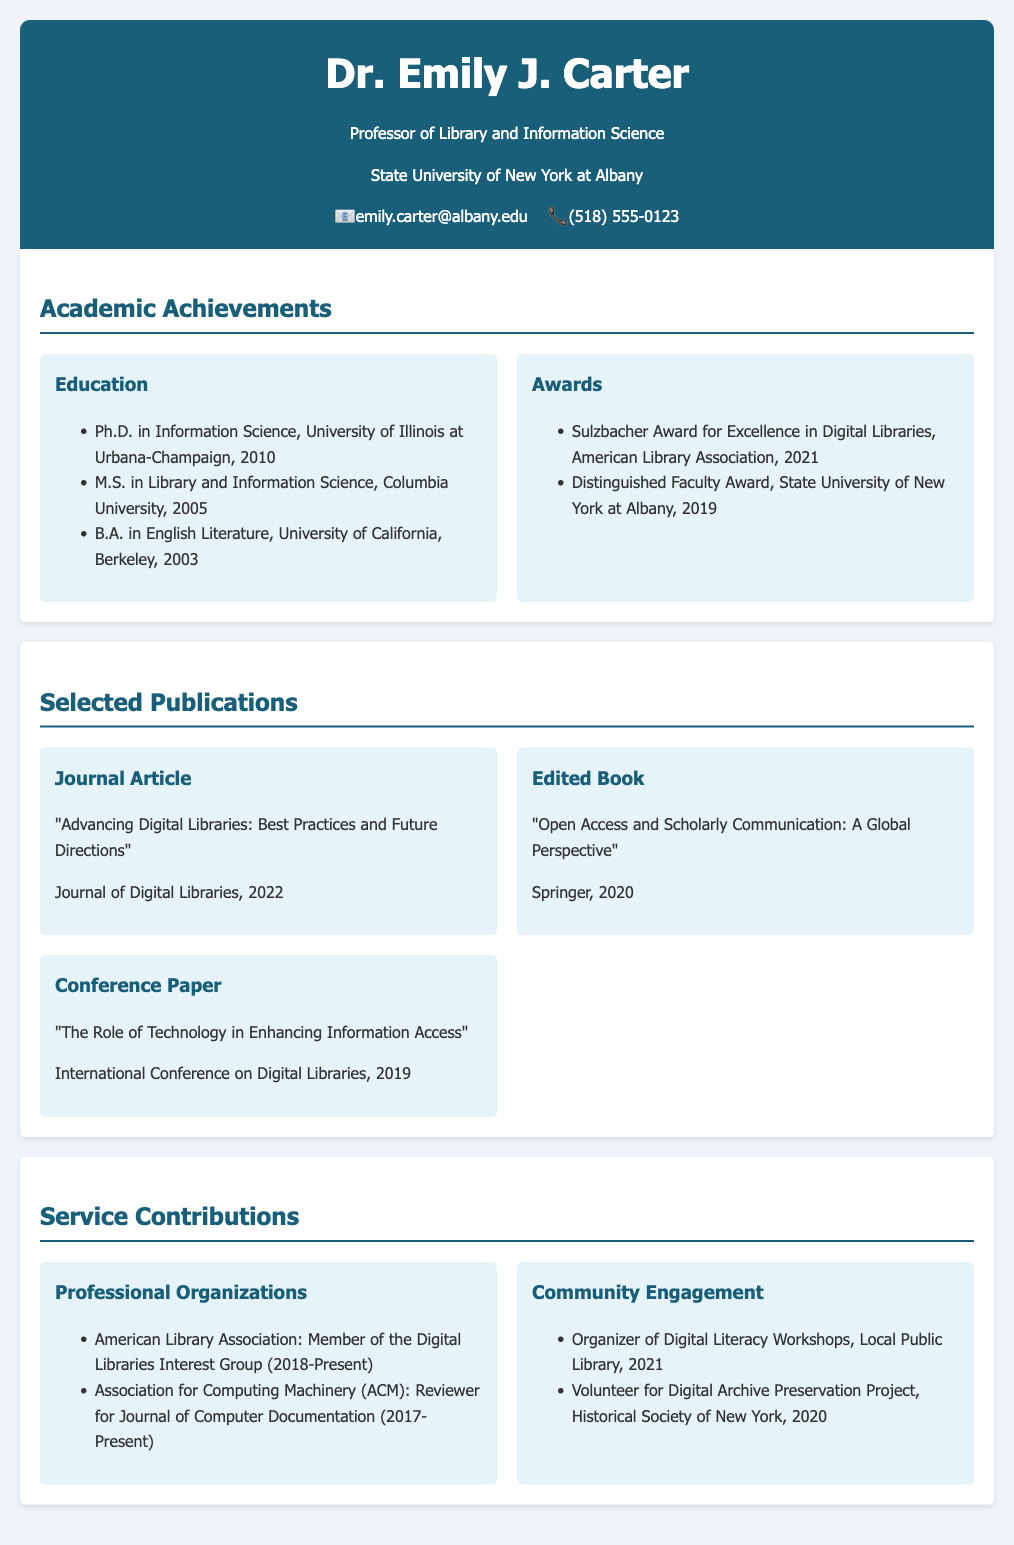what is Dr. Emily J. Carter's highest degree? The highest degree listed in the academic achievements section is Ph.D. in Information Science.
Answer: Ph.D. in Information Science which award did Dr. Carter receive in 2021? The award listed under achievements for the year 2021 is the Sulzbacher Award for Excellence in Digital Libraries.
Answer: Sulzbacher Award for Excellence in Digital Libraries how many years has Dr. Carter been a member of the Digital Libraries Interest Group? The membership with the American Library Association's Digital Libraries Interest Group started in 2018 and is present now, which indicates 5 years.
Answer: 5 years what is the title of Dr. Carter's edited book? The title listed for the edited book published in 2020 is "Open Access and Scholarly Communication: A Global Perspective."
Answer: Open Access and Scholarly Communication: A Global Perspective who published Dr. Carter's 2022 journal article? The publisher of the journal listed for Dr. Carter's 2022 journal article is the Journal of Digital Libraries.
Answer: Journal of Digital Libraries what type of contribution does Dr. Carter make to the ACM? Dr. Carter's contribution to the Association for Computing Machinery (ACM) is as a reviewer for the Journal of Computer Documentation.
Answer: Reviewer for Journal of Computer Documentation how many digital literacy workshops did Dr. Carter organize? The document states that Dr. Carter organized Digital Literacy Workshops in the Local Public Library in 2021, referring to one organized event.
Answer: 1 what is the primary area of Dr. Carter's academic focus? The title under Dr. Carter's name is Professor of Library and Information Science, which indicates her academic focus area.
Answer: Library and Information Science which university did Dr. Carter attend for her undergraduate degree? According to the academic achievements section, Dr. Carter obtained her undergraduate degree from the University of California, Berkeley.
Answer: University of California, Berkeley 